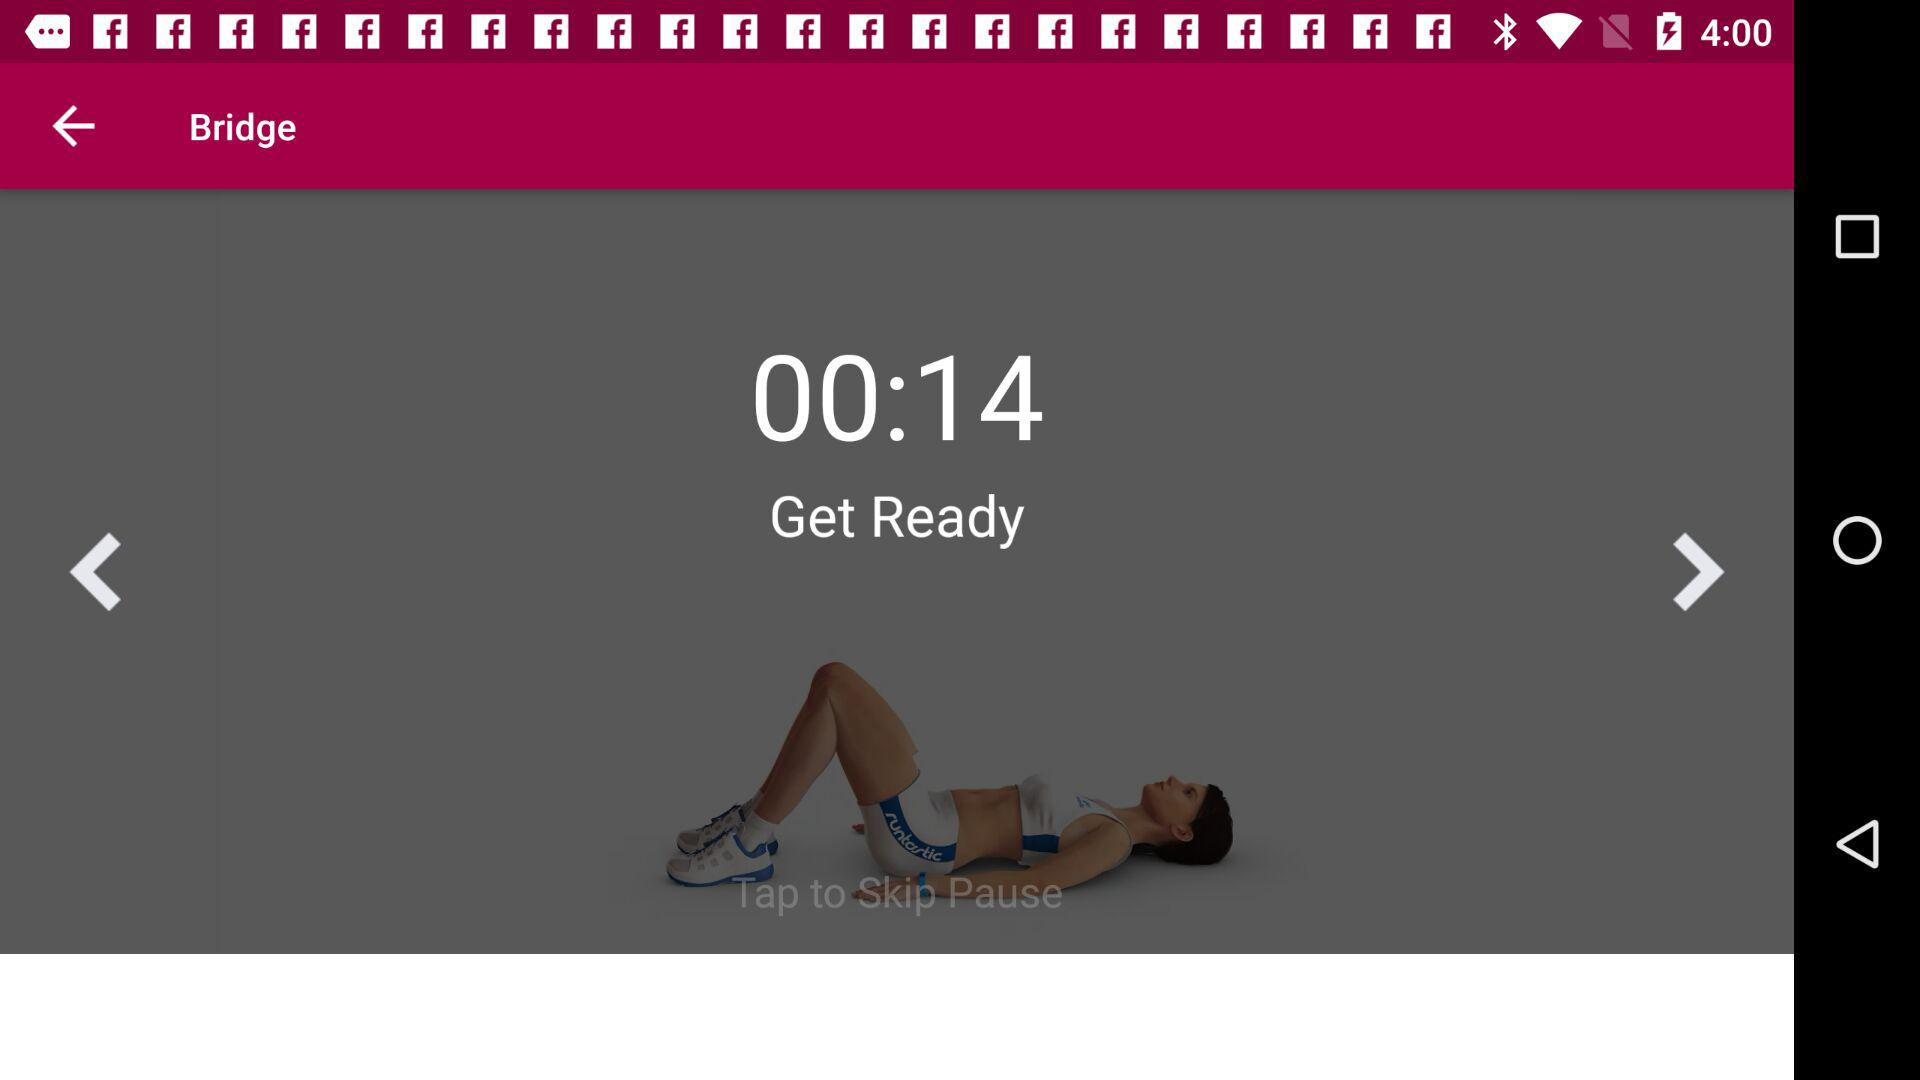Through which application can logging in be done? Logging in can be done through "Google" and "Facebook". 